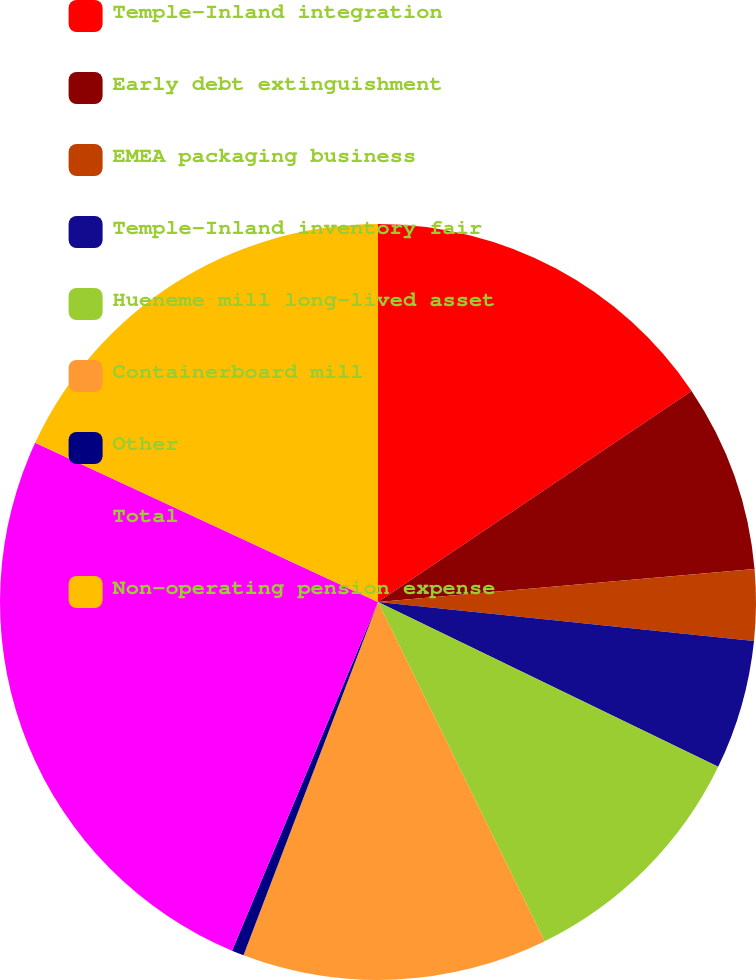<chart> <loc_0><loc_0><loc_500><loc_500><pie_chart><fcel>Temple-Inland integration<fcel>Early debt extinguishment<fcel>EMEA packaging business<fcel>Temple-Inland inventory fair<fcel>Hueneme mill long-lived asset<fcel>Containerboard mill<fcel>Other<fcel>Total<fcel>Non-operating pension expense<nl><fcel>15.57%<fcel>8.04%<fcel>3.03%<fcel>5.54%<fcel>10.55%<fcel>13.06%<fcel>0.52%<fcel>25.61%<fcel>18.08%<nl></chart> 